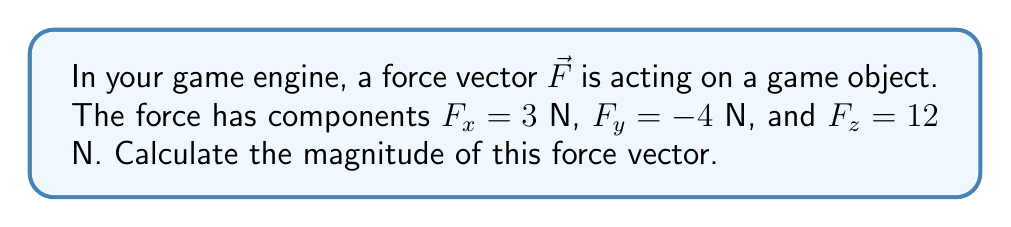What is the answer to this math problem? To find the magnitude of a force vector, we need to follow these steps:

1. Identify the components of the force vector:
   $F_x = 3$ N
   $F_y = -4$ N
   $F_z = 12$ N

2. Use the formula for the magnitude of a 3D vector:
   $$|\vec{F}| = \sqrt{F_x^2 + F_y^2 + F_z^2}$$

3. Substitute the values into the formula:
   $$|\vec{F}| = \sqrt{(3)^2 + (-4)^2 + (12)^2}$$

4. Calculate the squares:
   $$|\vec{F}| = \sqrt{9 + 16 + 144}$$

5. Sum the values under the square root:
   $$|\vec{F}| = \sqrt{169}$$

6. Calculate the square root:
   $$|\vec{F}| = 13$$

Therefore, the magnitude of the force vector is 13 N.
Answer: $13$ N 